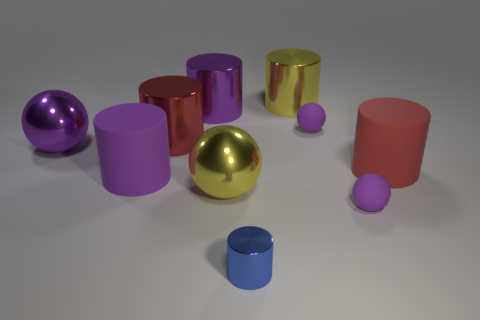There is another big red object that is the same shape as the large red metallic object; what is its material?
Offer a terse response. Rubber. What is the material of the big red object that is on the left side of the large yellow shiny cylinder?
Give a very brief answer. Metal. Does the purple shiny cylinder have the same size as the blue shiny thing?
Offer a terse response. No. Are there more yellow metallic things that are to the right of the tiny blue shiny cylinder than gray metal things?
Make the answer very short. Yes. The blue object that is made of the same material as the large yellow cylinder is what size?
Offer a terse response. Small. There is a large red shiny cylinder; are there any big purple shiny cylinders to the right of it?
Offer a very short reply. Yes. Is the small blue thing the same shape as the large red rubber object?
Your answer should be very brief. Yes. There is a purple ball that is left of the small matte ball that is behind the big yellow metallic object left of the blue object; what is its size?
Provide a succinct answer. Large. What material is the large yellow sphere?
Your answer should be very brief. Metal. Does the large red rubber object have the same shape as the large yellow shiny thing to the right of the large yellow metallic sphere?
Offer a very short reply. Yes. 